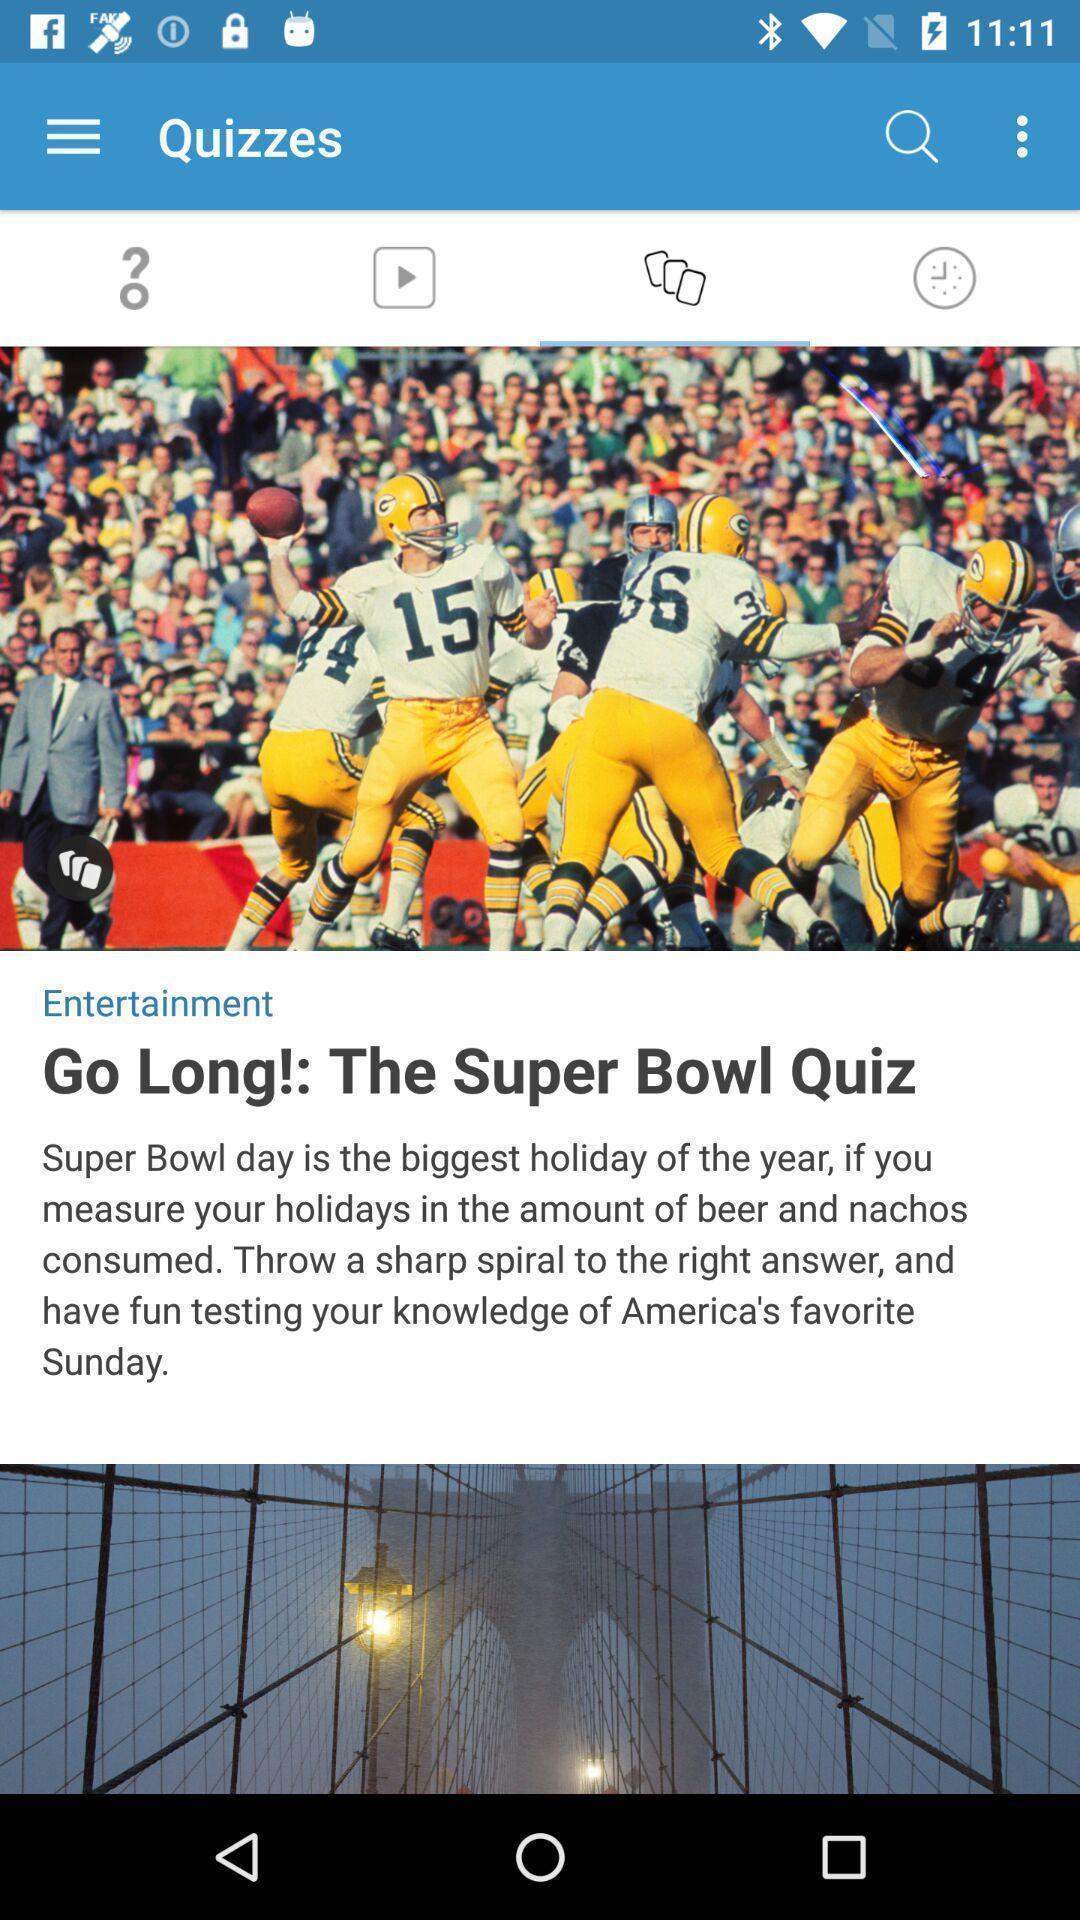Please provide a description for this image. Window displaying a page for quiz. 